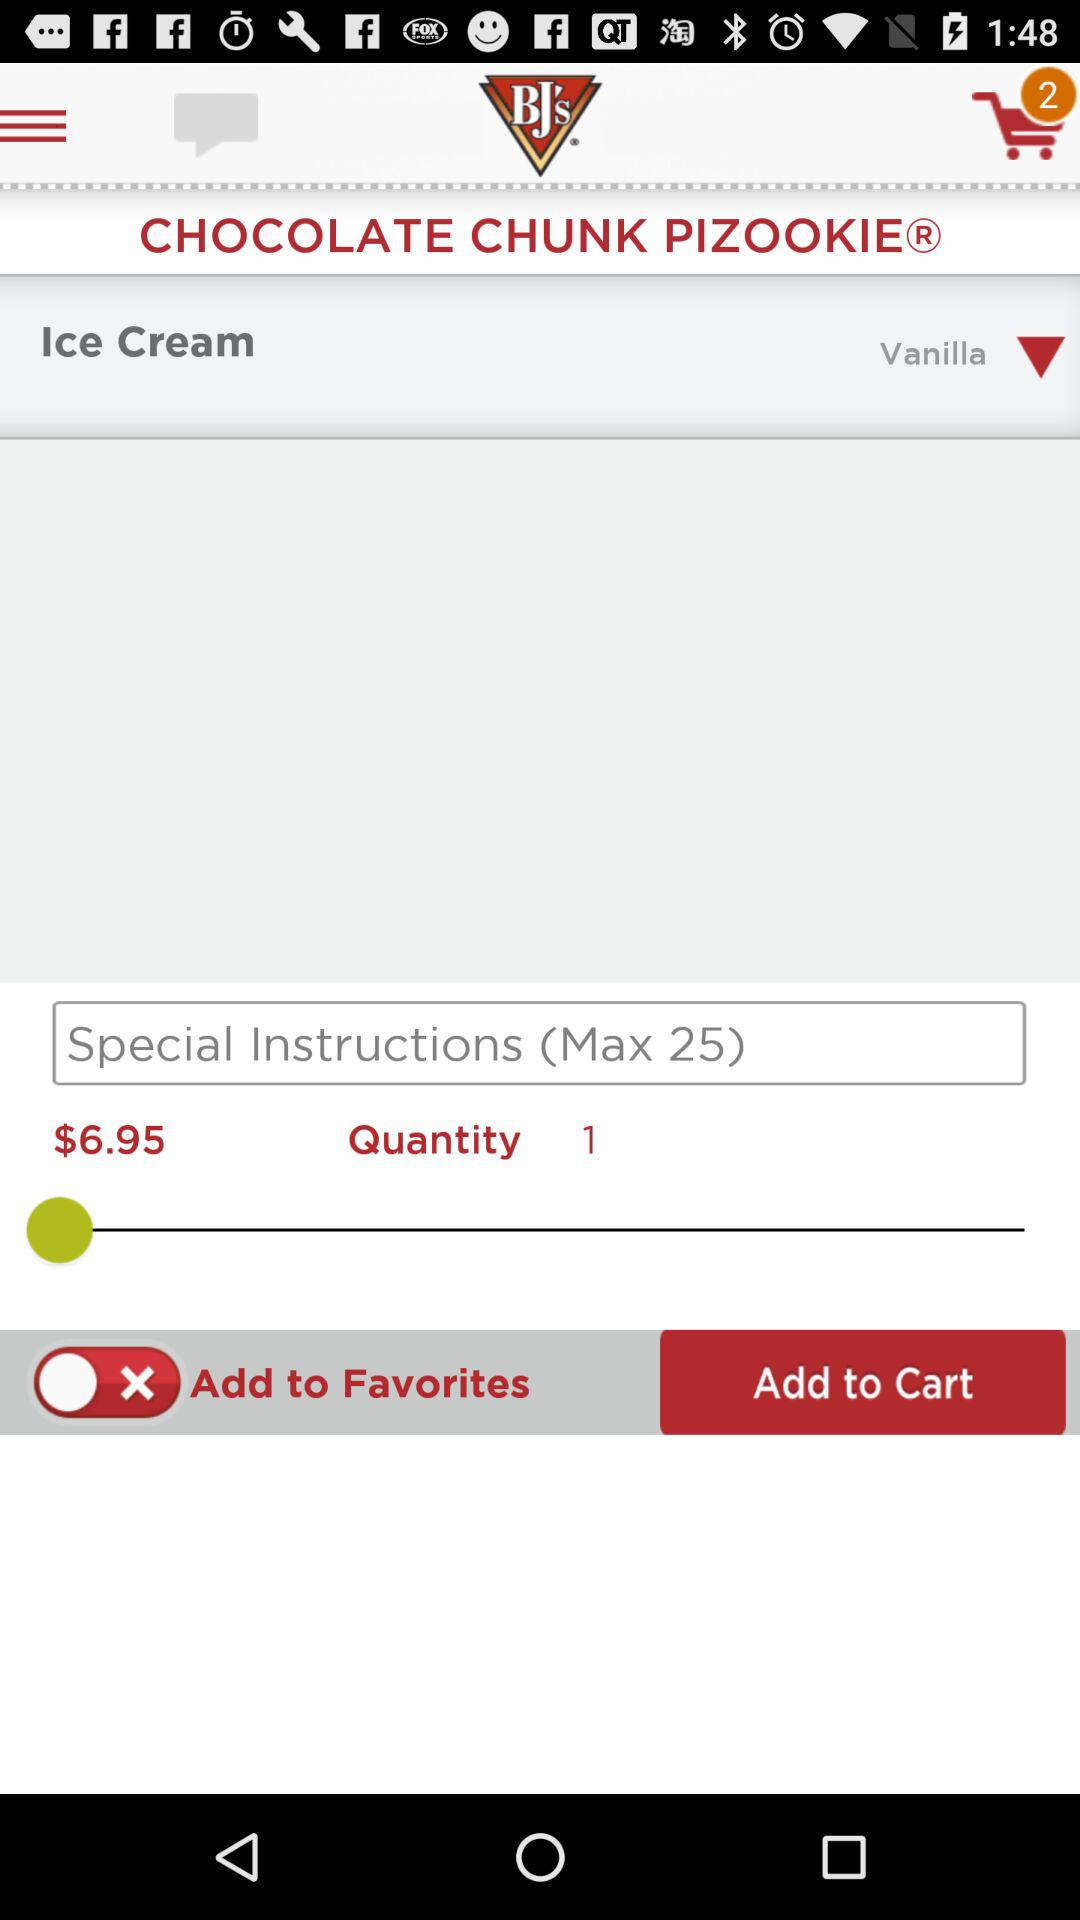What is the flavor of the ice cream? The flavor of the ice cream is "Vanilla". 